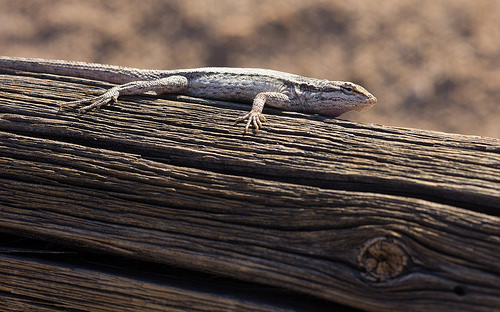<image>
Can you confirm if the lizard is behind the tree? No. The lizard is not behind the tree. From this viewpoint, the lizard appears to be positioned elsewhere in the scene. 